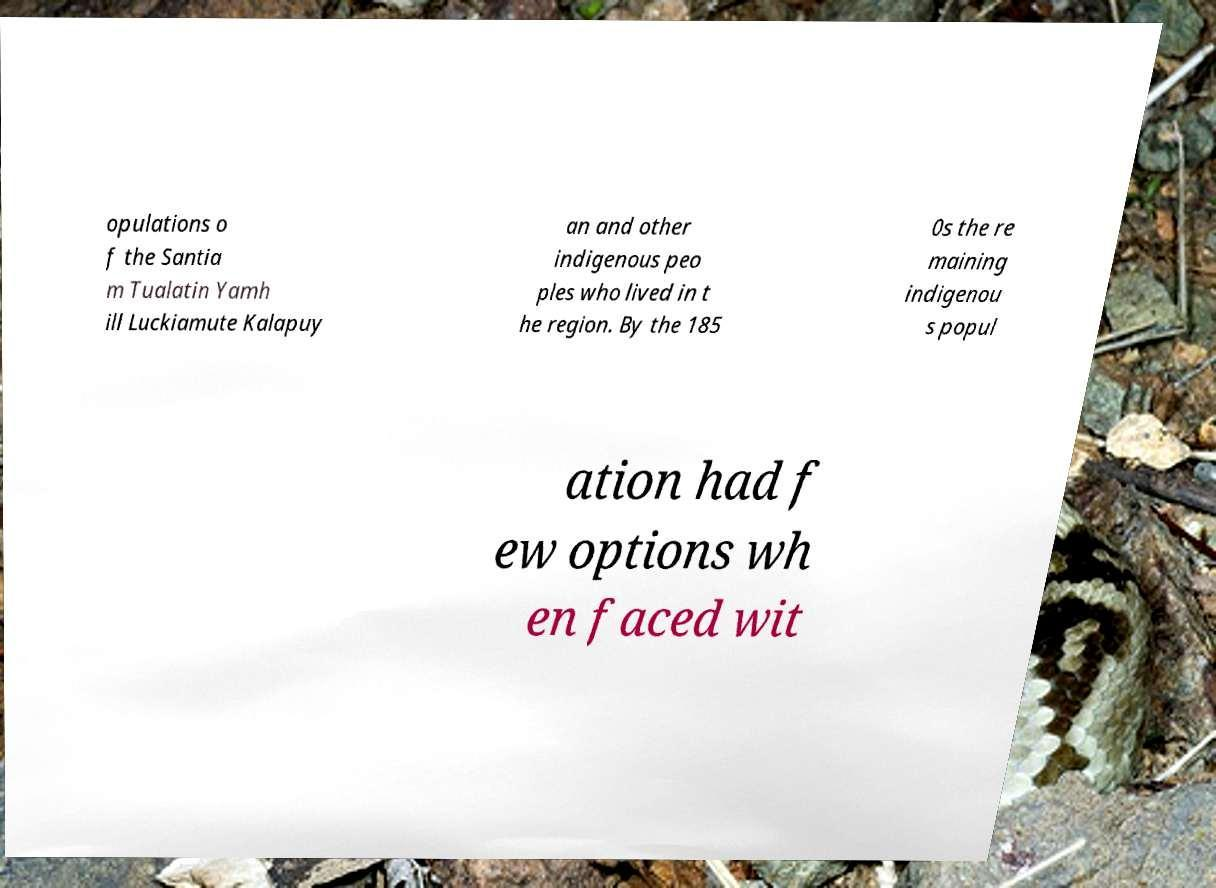Can you accurately transcribe the text from the provided image for me? opulations o f the Santia m Tualatin Yamh ill Luckiamute Kalapuy an and other indigenous peo ples who lived in t he region. By the 185 0s the re maining indigenou s popul ation had f ew options wh en faced wit 